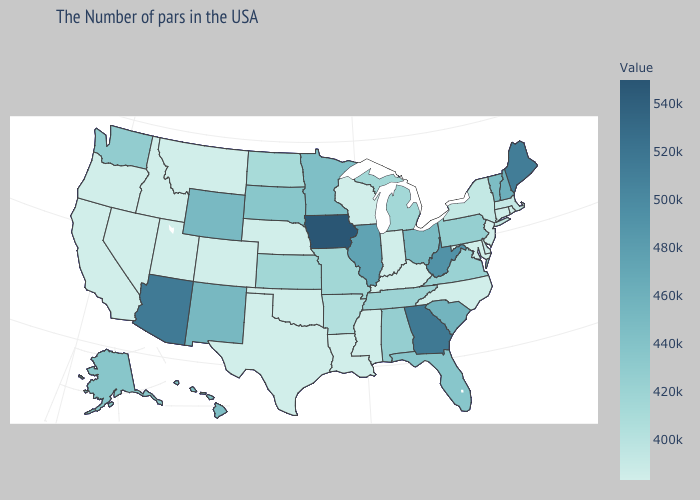Does Montana have the lowest value in the USA?
Give a very brief answer. Yes. Which states have the lowest value in the MidWest?
Concise answer only. Indiana, Wisconsin, Nebraska. Does North Dakota have the lowest value in the MidWest?
Be succinct. No. Among the states that border Rhode Island , does Connecticut have the lowest value?
Give a very brief answer. Yes. Does Massachusetts have the lowest value in the Northeast?
Keep it brief. No. Among the states that border Illinois , which have the lowest value?
Keep it brief. Kentucky, Indiana, Wisconsin. 